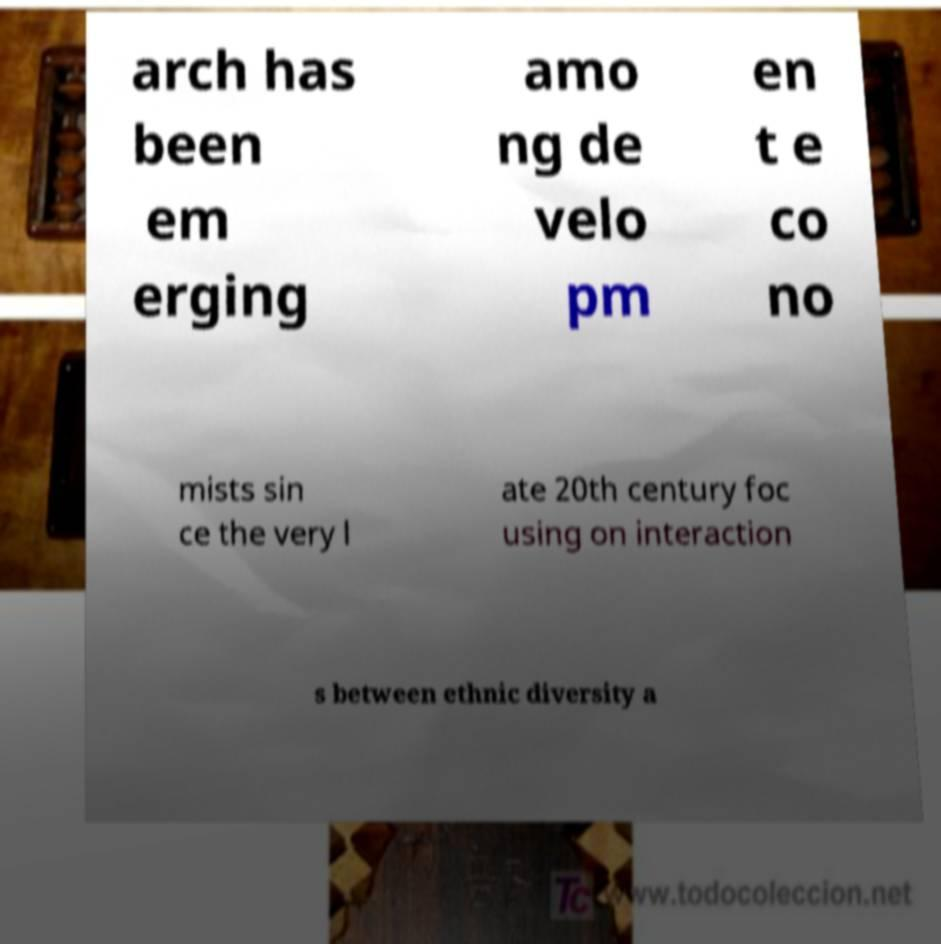I need the written content from this picture converted into text. Can you do that? arch has been em erging amo ng de velo pm en t e co no mists sin ce the very l ate 20th century foc using on interaction s between ethnic diversity a 